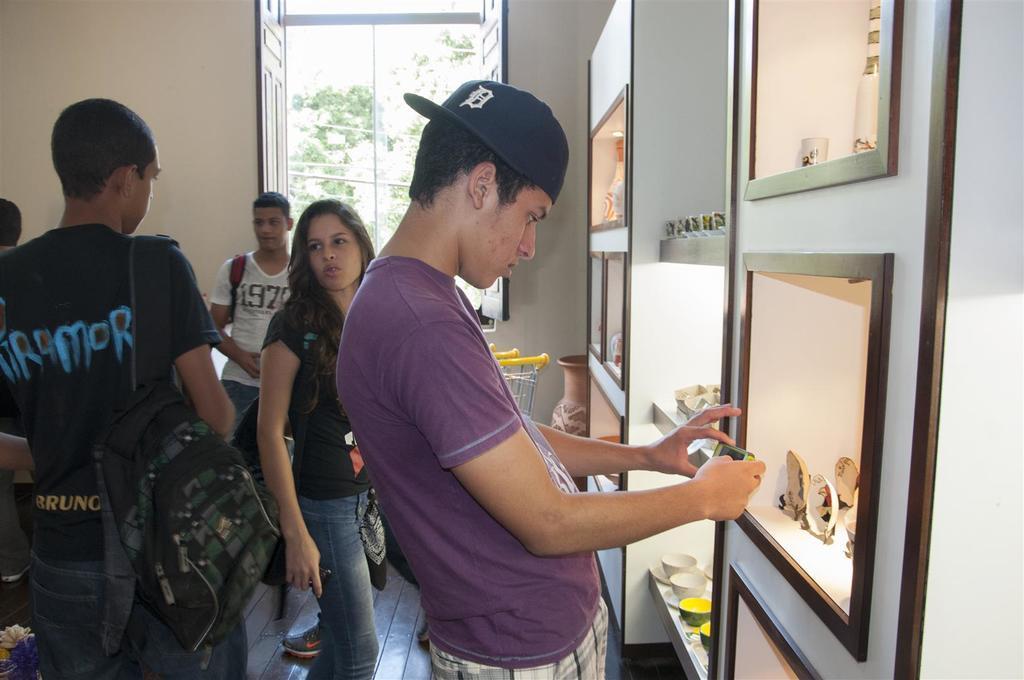Could you give a brief overview of what you see in this image? On the right side of the image we can see a person's standing at the cupboards. On the left side of the image we can see a person's standing on the floor. On the right side we can see an objects placed in the cupboards. In the background we can see wall, window and trees. 